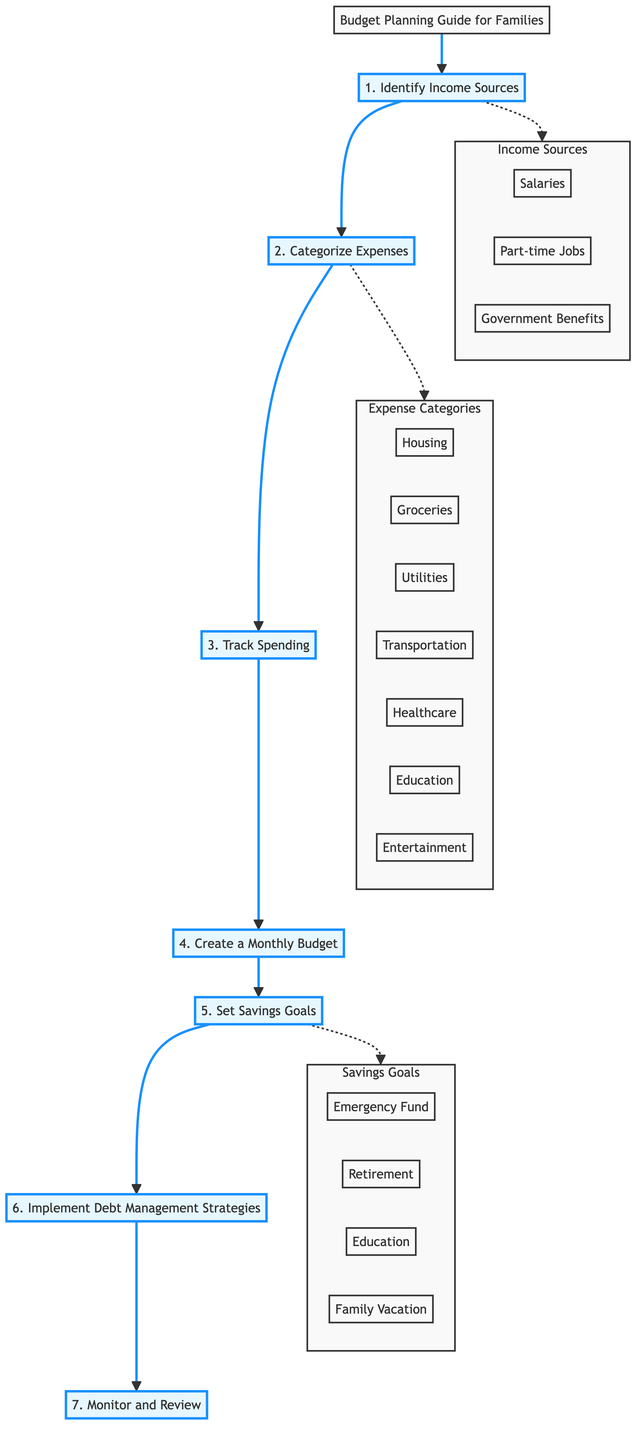What is the first step in the budget planning process? The diagram shows that the first step is to identify income sources, as indicated by the arrow leading from the title to the first node.
Answer: Identify Income Sources How many expense categories are listed in the diagram? By counting the nodes under the expense categories section, we find that there are seven expense categories: housing, groceries, utilities, transportation, healthcare, education, and entertainment.
Answer: 7 What is the last step in the process? The flowchart indicates that the last step is to monitor and review, as it is the final node in the sequence of steps.
Answer: Monitor and Review Which section includes an emergency fund? The savings goals section contains the item emergency fund, which is one of the goals listed within that section.
Answer: Savings Goals What connects 'Track Spending' and 'Create a Monthly Budget'? The connection between 'Track Spending' and 'Create a Monthly Budget' is an arrow, indicating that tracking spending follows tracking expenses to create a budget.
Answer: Arrow How many income sources are mentioned in the diagram? The diagram depicts three income sources: salaries, part-time jobs, and government benefits, all grouped under the income sources section.
Answer: 3 What is required after setting savings goals in the budget planning process? After setting savings goals, the next required action is to implement debt management strategies, as seen from the flowchart's sequential steps.
Answer: Implement Debt Management Strategies What type of diagram is this? This diagram is a flowchart that outlines a step-by-step process for budget planning for families, featuring various sections and processes.
Answer: Flowchart What do the dashed lines represent in the diagram? The dashed lines connect the main process steps to their respective categories, showing the relationships between steps and their content, such as income sources, expenses, and savings.
Answer: Dashed lines represent connections 